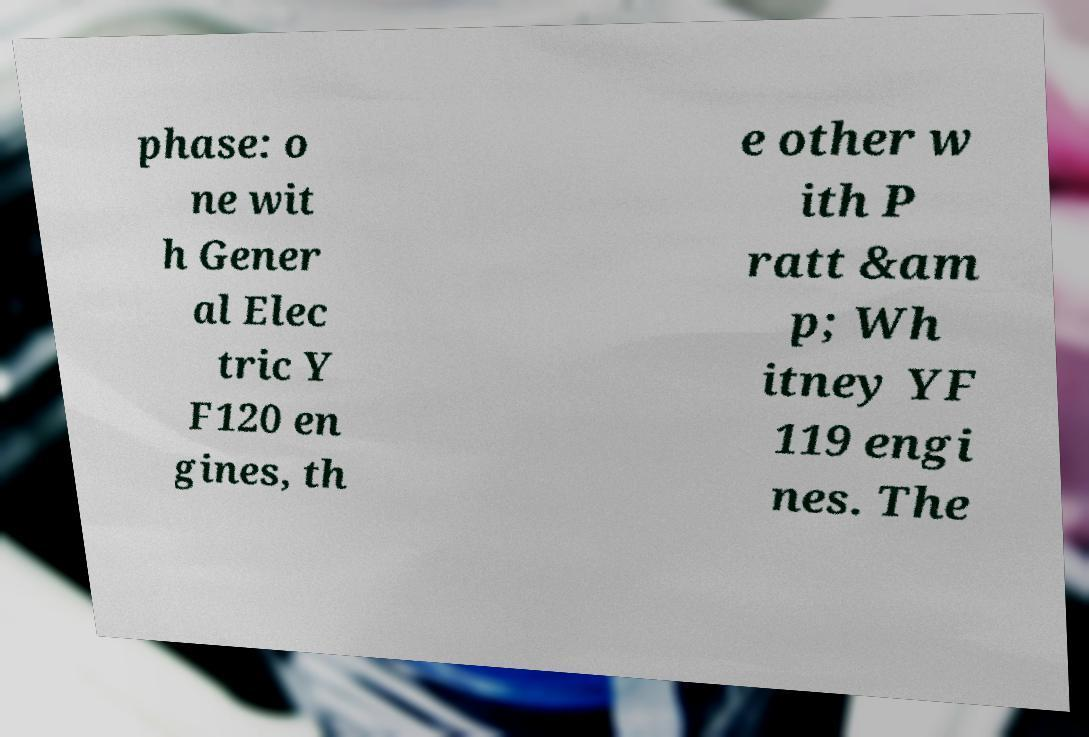Please read and relay the text visible in this image. What does it say? phase: o ne wit h Gener al Elec tric Y F120 en gines, th e other w ith P ratt &am p; Wh itney YF 119 engi nes. The 